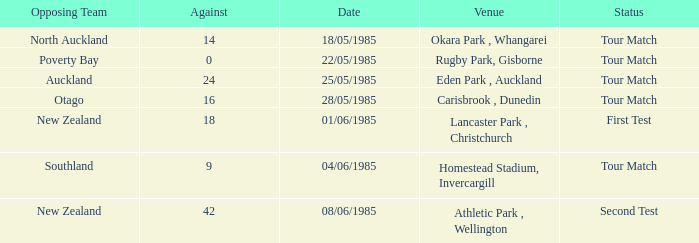Which opposite team had an against score lesser than 42 and a tour match status at rugby park, gisborne? Poverty Bay. 